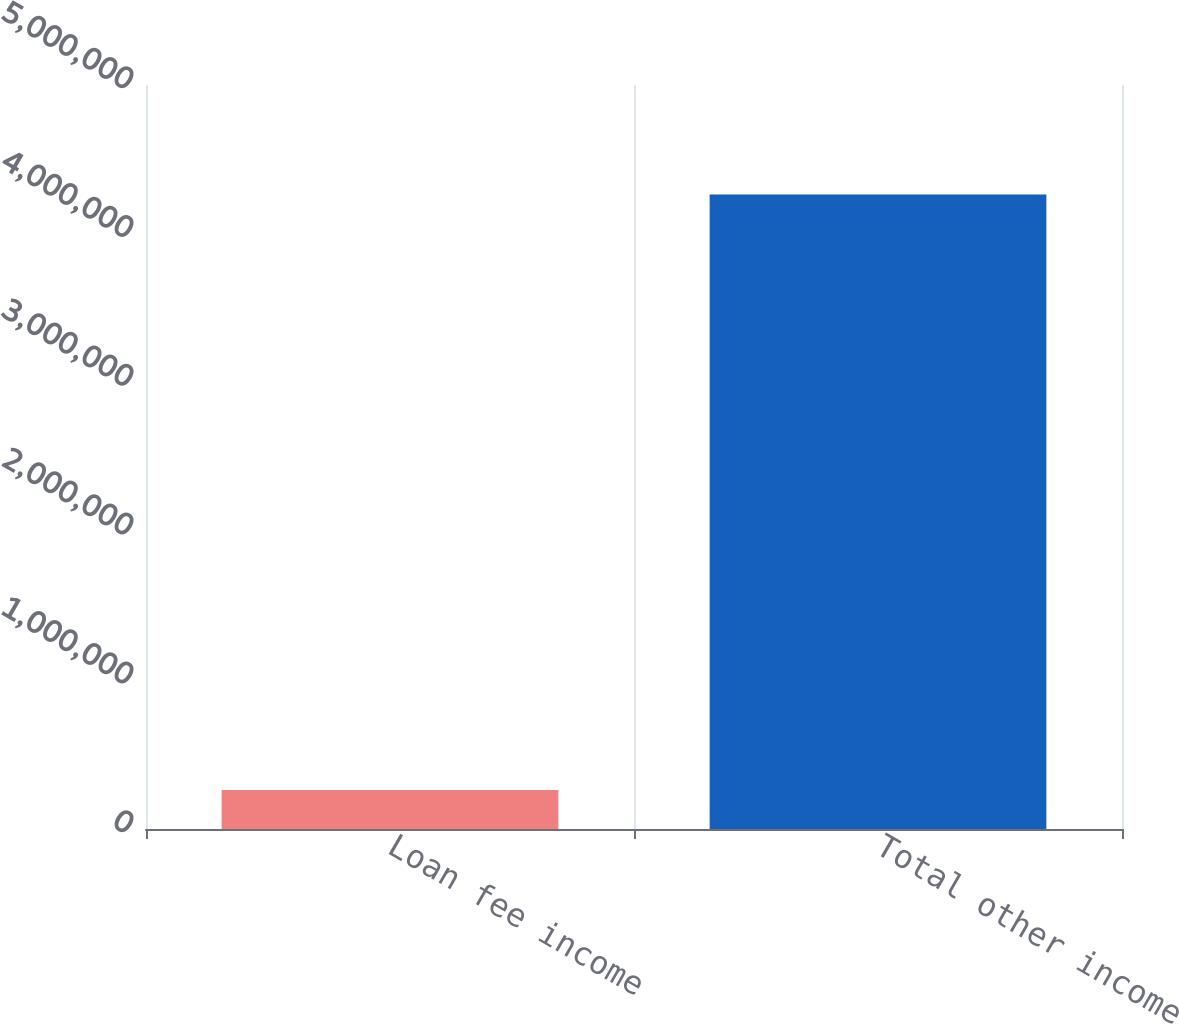<chart> <loc_0><loc_0><loc_500><loc_500><bar_chart><fcel>Loan fee income<fcel>Total other income<nl><fcel>262576<fcel>4.26446e+06<nl></chart> 